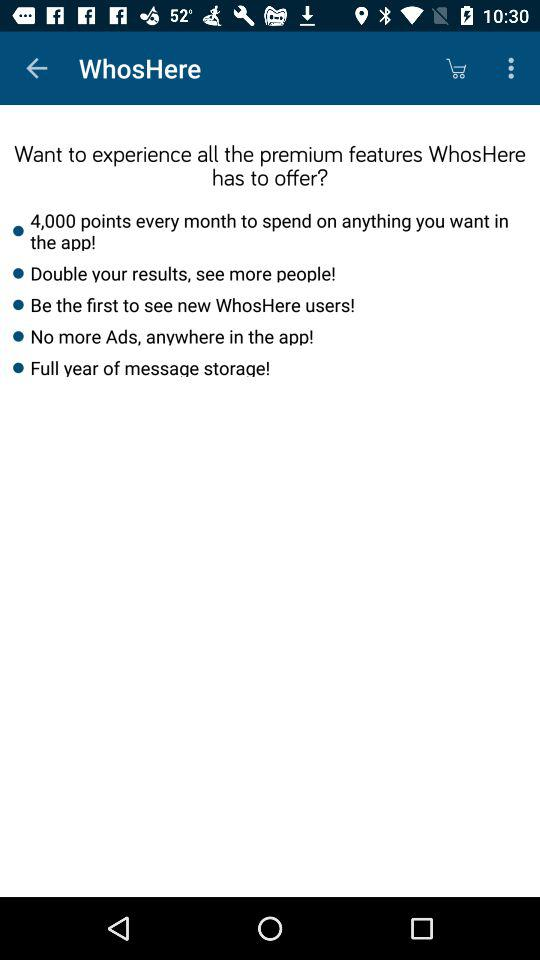Can you tell me more about the premium features listed? Certainly! The premium features of the app, as listed, include the ability to receive 4,000 points monthly to spend within the app, an option to double your results thereby seeing more people, exclusive access to be among the first to view new WhosHere users, an ad-free experience throughout the app, and a full year of message storage. 